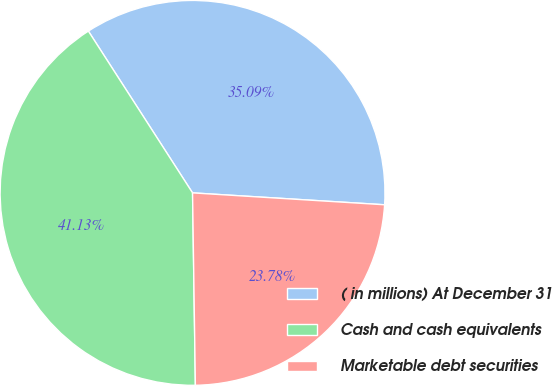<chart> <loc_0><loc_0><loc_500><loc_500><pie_chart><fcel>( in millions) At December 31<fcel>Cash and cash equivalents<fcel>Marketable debt securities<nl><fcel>35.09%<fcel>41.13%<fcel>23.78%<nl></chart> 